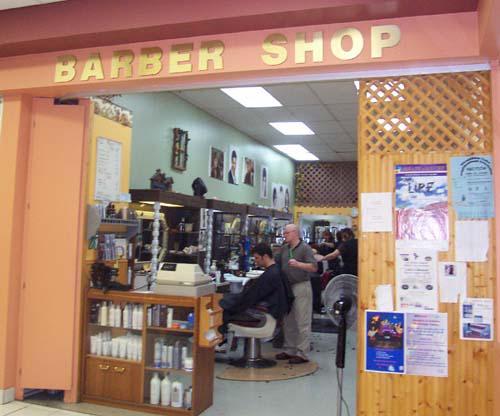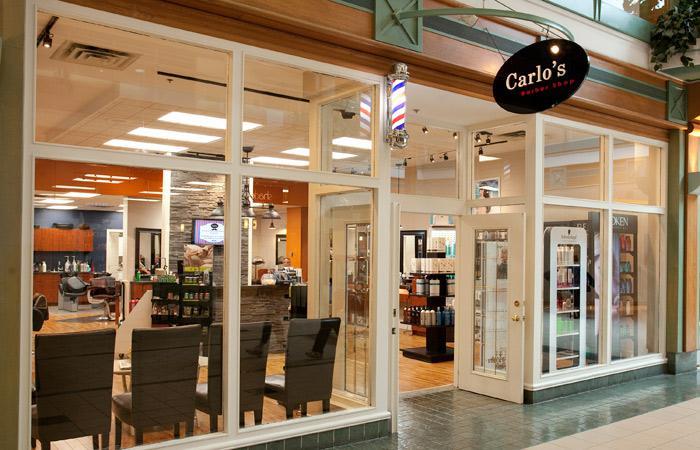The first image is the image on the left, the second image is the image on the right. Given the left and right images, does the statement "There is a barber pole in the image on the right." hold true? Answer yes or no. Yes. 